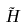Convert formula to latex. <formula><loc_0><loc_0><loc_500><loc_500>\tilde { H }</formula> 